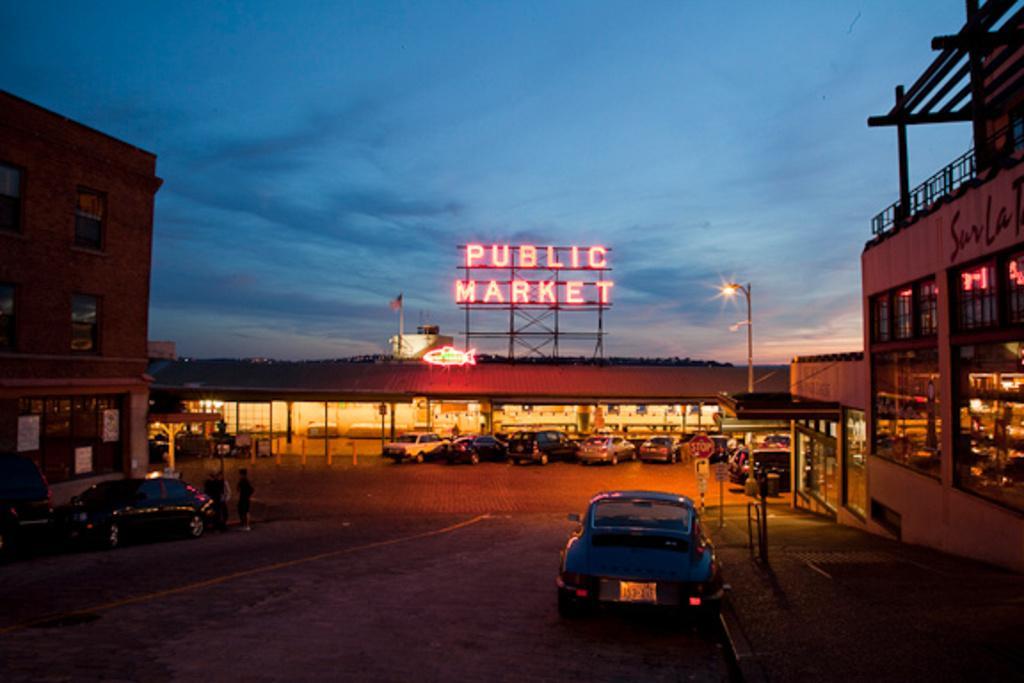Describe this image in one or two sentences. In this image we can see buildings, a board and a flag on the building, there are cars on the road and two people standing near a car, there is a street light and a sign board near the building. 